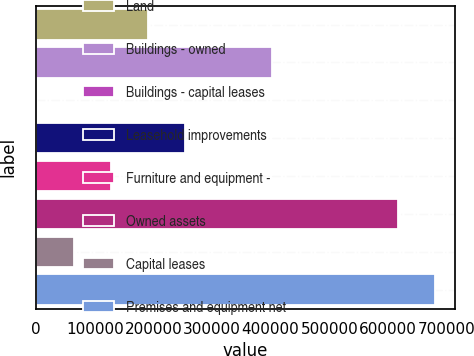Convert chart to OTSL. <chart><loc_0><loc_0><loc_500><loc_500><bar_chart><fcel>Land<fcel>Buildings - owned<fcel>Buildings - capital leases<fcel>Leasehold improvements<fcel>Furniture and equipment -<fcel>Owned assets<fcel>Capital leases<fcel>Premises and equipment net<nl><fcel>190848<fcel>402065<fcel>1131<fcel>254087<fcel>127609<fcel>617228<fcel>64369.9<fcel>680467<nl></chart> 